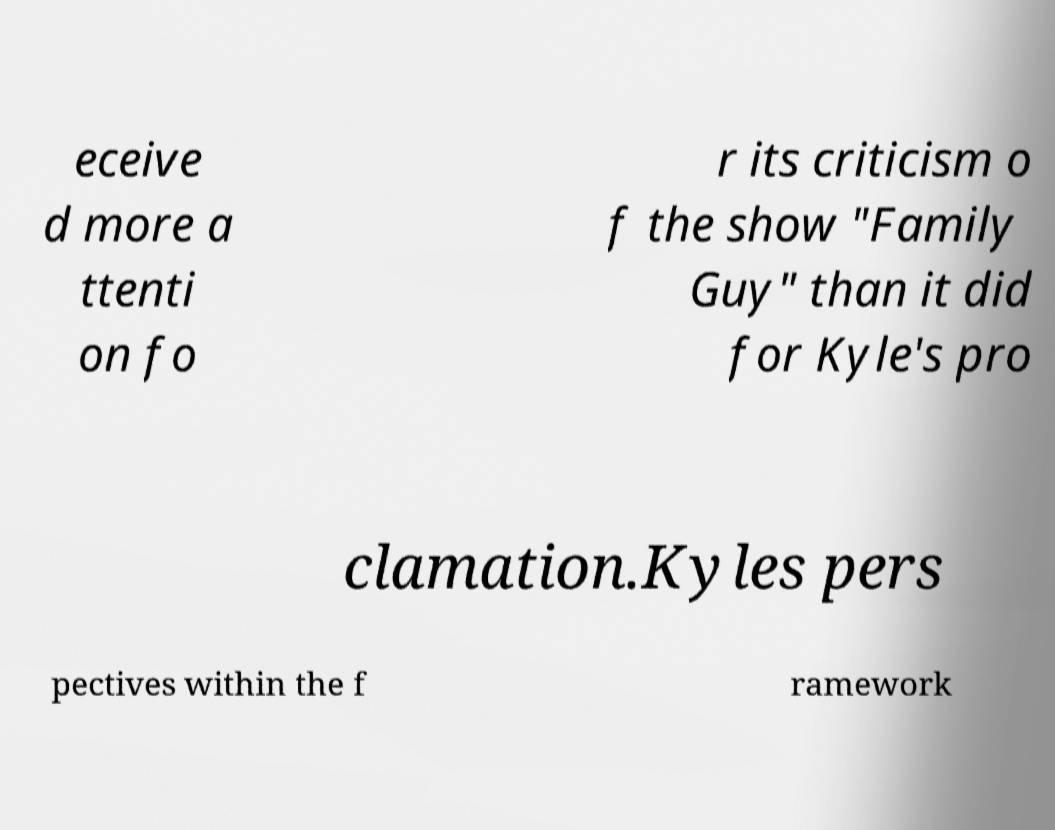I need the written content from this picture converted into text. Can you do that? eceive d more a ttenti on fo r its criticism o f the show "Family Guy" than it did for Kyle's pro clamation.Kyles pers pectives within the f ramework 